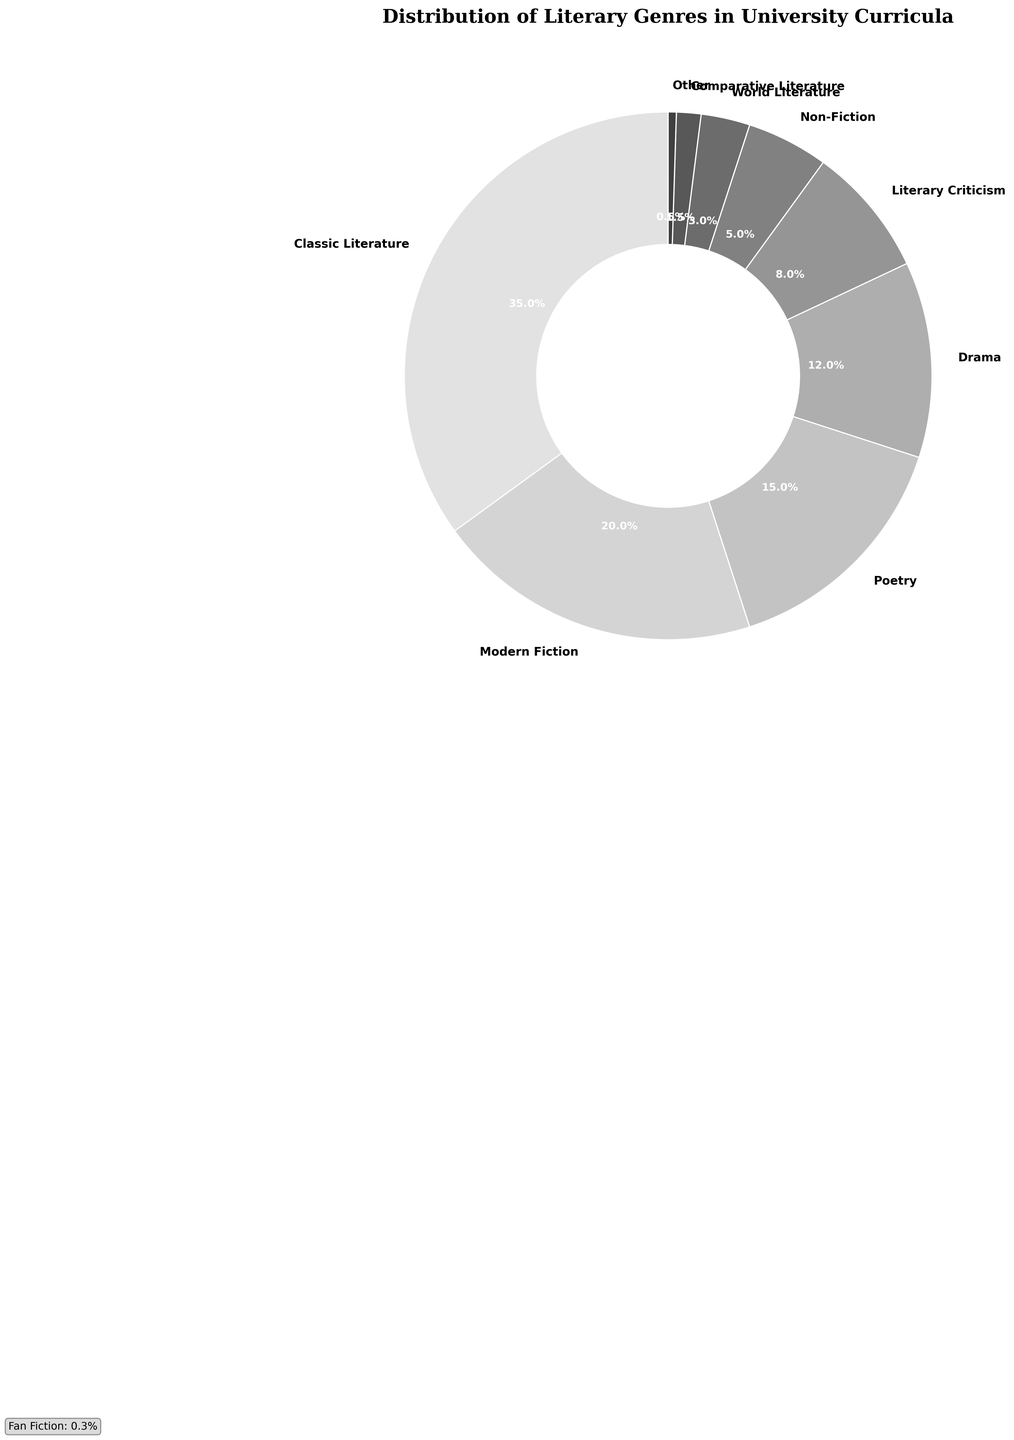Which genre has the highest percentage in the curriculum? On the chart, the segment representing Classic Literature is the largest compared to other genres.
Answer: Classic Literature What is the combined percentage of Modern Fiction and Drama? According to the figure, Modern Fiction has a percentage of 20%, and Drama has a percentage of 12%. Summing these values gives us 32%.
Answer: 32% How does the percentage of Poetry compare to Non-Fiction? The percentage shown for Poetry is 15%, whereas Non-Fiction has a lower percentage of 5%. Thus, Poetry has a higher percentage.
Answer: Poetry has a higher percentage What is the least represented genre in the university curricula? By examining the chart, Fan Fiction and Genre Fiction have the smallest segments. Specifically, Fan Fiction is 0.3%, and Genre Fiction is 0.2%. Genre Fiction's segment is the smallest.
Answer: Genre Fiction What is the total percentage of genres classified under "Other"? The figure combines World Literature, Comparative Literature, Fan Fiction, and Genre Fiction under "Other." Summing their percentages, we get 3% + 1.5% + 0.3% + 0.2% = 5%.
Answer: 5% What percentage is shown for Literary Criticism? The pie chart shows a specific segment for Literary Criticism, which is 8%.
Answer: 8% Is the percentage of Drama greater than, less than, or equal to that of Poetry? The chart shows Drama at 12% and Poetry at 15%. Hence, Drama's percentage is less than that of Poetry.
Answer: Less than If you sum the percentage of Classic Literature, Modern Fiction, and Poetry, what do you get? Adding the percentages: Classic Literature (35%) + Modern Fiction (20%) + Poetry (15%) equals 70%.
Answer: 70% Which genre has a larger percentage: World Literature or Comparative Literature? The given chart shows World Literature with 3% and Comparative Literature with 1.5%. Thus, World Literature has a larger percentage.
Answer: World Literature How much more percentage does Modern Fiction have compared to Literary Criticism? The chart shows Modern Fiction at 20% and Literary Criticism at 8%. The difference (20% - 8%) is 12%.
Answer: 12% 